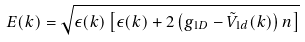Convert formula to latex. <formula><loc_0><loc_0><loc_500><loc_500>E ( k ) = \sqrt { \epsilon ( k ) \left [ \epsilon ( k ) + 2 \left ( g _ { 1 D } - \tilde { V } _ { 1 d } ( k ) \right ) n \right ] }</formula> 